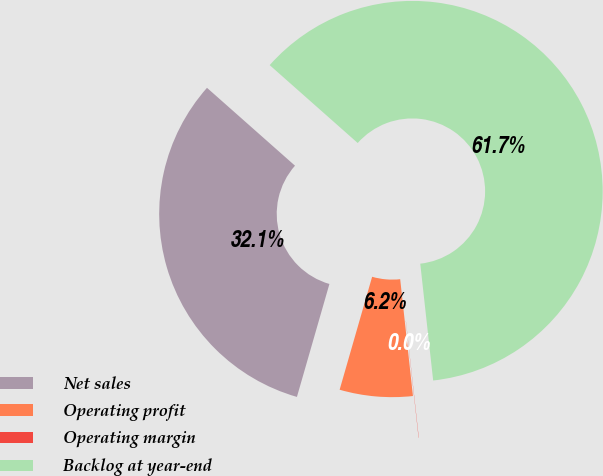<chart> <loc_0><loc_0><loc_500><loc_500><pie_chart><fcel>Net sales<fcel>Operating profit<fcel>Operating margin<fcel>Backlog at year-end<nl><fcel>32.07%<fcel>6.19%<fcel>0.02%<fcel>61.72%<nl></chart> 